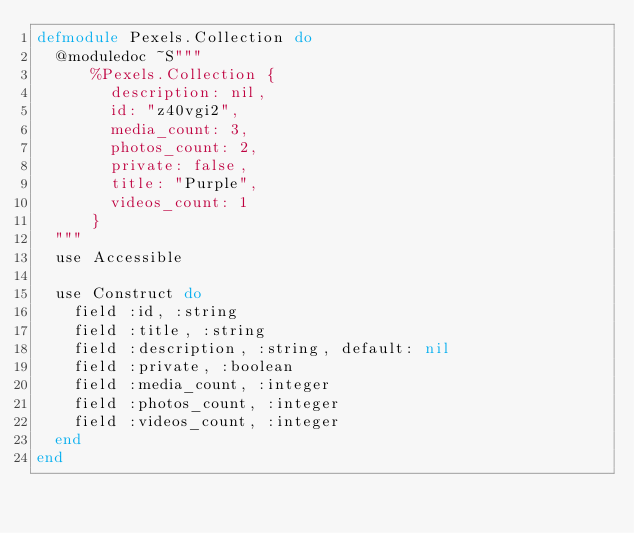Convert code to text. <code><loc_0><loc_0><loc_500><loc_500><_Elixir_>defmodule Pexels.Collection do  
  @moduledoc ~S"""
      %Pexels.Collection {
        description: nil,
        id: "z40vgi2",
        media_count: 3,
        photos_count: 2,
        private: false,
        title: "Purple",
        videos_count: 1
      }
  """
  use Accessible

  use Construct do
    field :id, :string
    field :title, :string
    field :description, :string, default: nil
    field :private, :boolean
    field :media_count, :integer
    field :photos_count, :integer
    field :videos_count, :integer
  end
end
</code> 